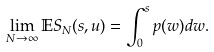<formula> <loc_0><loc_0><loc_500><loc_500>\lim _ { N \rightarrow \infty } \mathbb { E } S _ { N } ( s , u ) = \int _ { 0 } ^ { s } p ( w ) d w .</formula> 